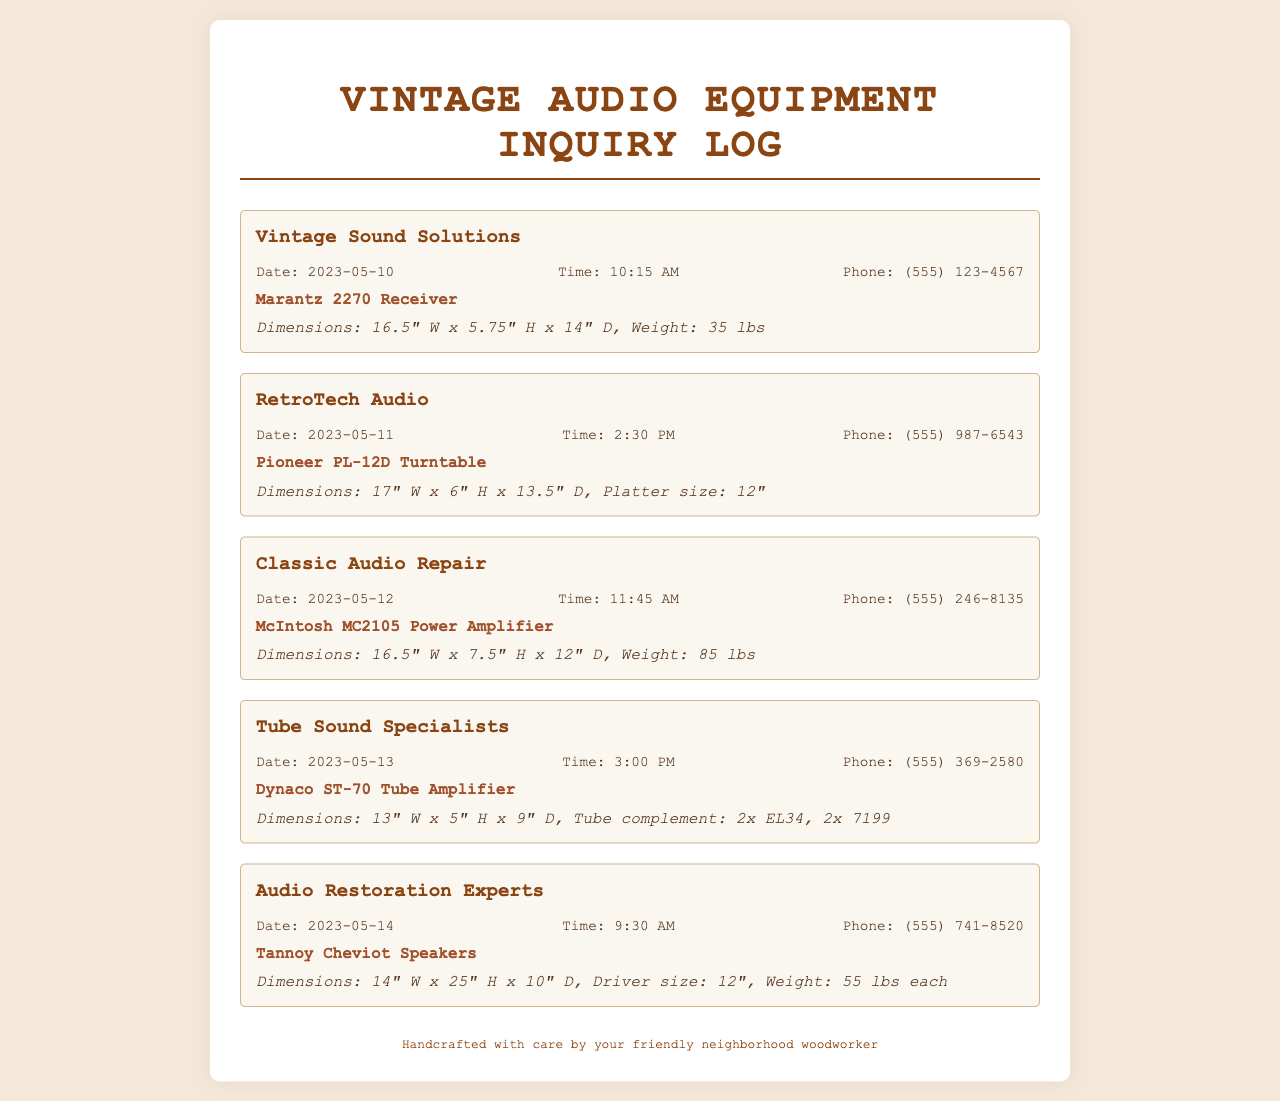What is the phone number for Vintage Sound Solutions? The phone number is given under the corresponding call log for Vintage Sound Solutions.
Answer: (555) 123-4567 When was the call to RetroTech Audio made? The date of the call is mentioned in the log for RetroTech Audio.
Answer: 2023-05-11 What is the weight of the McIntosh MC2105 Power Amplifier? The weight is specified in the notes section for the McIntosh MC2105 Power Amplifier.
Answer: 85 lbs Which equipment has the largest dimensions listed? This requires comparing the dimensions from all the call logs. The Tannoy Cheviot Speakers have the largest height.
Answer: 25" H Who did you call on May 12, 2023? The call log for that date reveals the name of the repair shop called.
Answer: Classic Audio Repair What is the platter size for the Pioneer PL-12D Turntable? The platter size is provided in the notes section for that equipment.
Answer: 12" How many pounds do the Tannoy Cheviot Speakers weigh each? The weight information is available in the notes for Tannoy Cheviot Speakers.
Answer: 55 lbs each What time was the call to Tube Sound Specialists made? The time of the call is noted in the call log for Tube Sound Specialists.
Answer: 3:00 PM Which repair shop was called last based on the log? This requires checking the chronological order of the calls. The last call was made to Audio Restoration Experts.
Answer: Audio Restoration Experts 